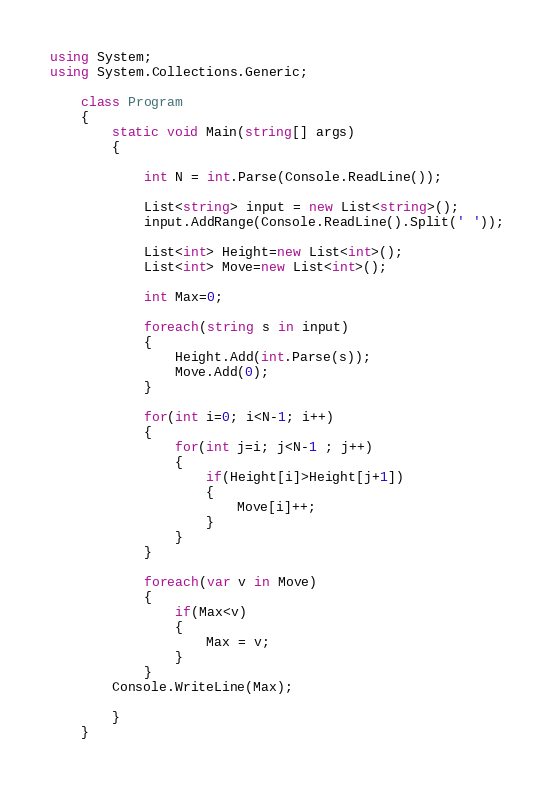<code> <loc_0><loc_0><loc_500><loc_500><_C#_>using System;
using System.Collections.Generic;

    class Program
    {
        static void Main(string[] args)
        {

            int N = int.Parse(Console.ReadLine());

            List<string> input = new List<string>();
            input.AddRange(Console.ReadLine().Split(' '));
            
            List<int> Height=new List<int>();
            List<int> Move=new List<int>();

            int Max=0;

            foreach(string s in input)
            {
                Height.Add(int.Parse(s));
                Move.Add(0);
            }

            for(int i=0; i<N-1; i++)
            {
                for(int j=i; j<N-1 ; j++)
                {
                    if(Height[i]>Height[j+1])
                    {
                        Move[i]++;
                    }
                }
            }

            foreach(var v in Move)
            {
                if(Max<v)
                {
                    Max = v;
                }            
            }
        Console.WriteLine(Max);

        }
    }
</code> 